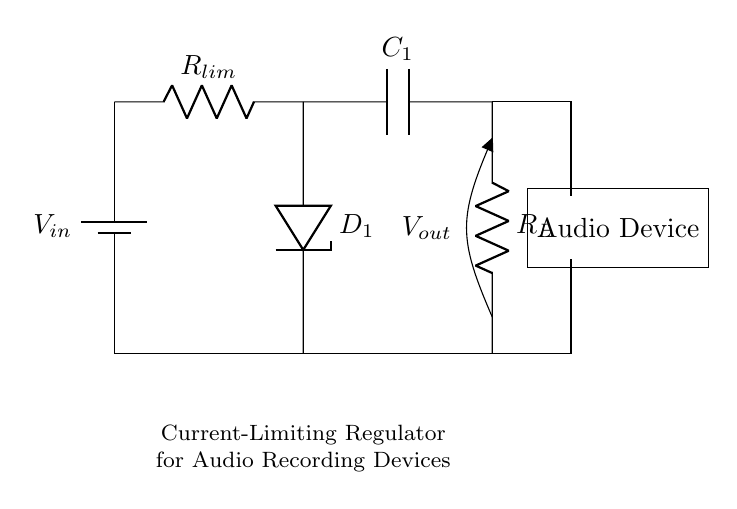What is the input voltage of this circuit? The circuit diagram labels the battery supplying power as $V_{in}$. This label indicates the voltage provided to the circuit, showing that it functions with that specific input.
Answer: $V_{in}$ What is the purpose of the Zener diode in this circuit? The Zener diode, labeled as $D_1$, is used for voltage regulation. It maintains the output voltage to a desired level by allowing current to flow in the reverse direction when the output exceeds a certain threshold, thus protecting the circuit from voltage spikes.
Answer: Voltage regulation What component limits the current in this circuit? The component labeled as $R_{lim}$ is the current-limiting resistor. It constrains the flow of current to the load, protecting sensitive devices from excessive current.
Answer: $R_{lim}$ What type of load does this circuit support? The load connected in this circuit is labeled as $R_L$, which represents a resistive load. It indicates that the circuit is designed to support devices like audio recording equipment that can be modeled as a resistor in the circuit.
Answer: Resistive load How does the output voltage relate to the input voltage? The output voltage, labeled as $V_{out}$, is regulated by the Zener diode. The current-limiting resistor in series with the Zener diode ensures that even if the input voltage varies, the output voltage remains stable, typically at the Zener voltage.
Answer: Stabilized What is the function of the output capacitor in the circuit? The output capacitor, labeled as $C_1$, is used for filtering. It smooths out any fluctuations in the voltage output, providing a steady voltage level to the load, which is crucial for audio devices that require stable power.
Answer: Filtering What could happen if the current-limiting resistor is removed? If $R_{lim}$ is removed, there would be no current limitation. This could lead to excessive current flowing through the circuit components, potentially damaging sensitive audio devices due to overcurrent conditions.
Answer: Damage risk 